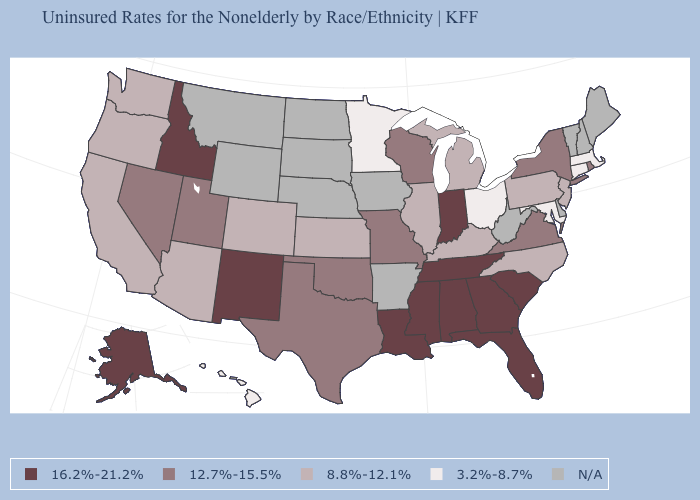Name the states that have a value in the range N/A?
Keep it brief. Arkansas, Delaware, Iowa, Maine, Montana, Nebraska, New Hampshire, North Dakota, South Dakota, Vermont, West Virginia, Wyoming. Among the states that border Louisiana , which have the lowest value?
Concise answer only. Texas. Among the states that border North Carolina , which have the highest value?
Concise answer only. Georgia, South Carolina, Tennessee. What is the value of Iowa?
Write a very short answer. N/A. Among the states that border Ohio , does Indiana have the highest value?
Write a very short answer. Yes. What is the value of New Jersey?
Answer briefly. 8.8%-12.1%. Name the states that have a value in the range 12.7%-15.5%?
Give a very brief answer. Missouri, Nevada, New York, Oklahoma, Rhode Island, Texas, Utah, Virginia, Wisconsin. What is the highest value in the USA?
Be succinct. 16.2%-21.2%. Name the states that have a value in the range 3.2%-8.7%?
Be succinct. Connecticut, Hawaii, Maryland, Massachusetts, Minnesota, Ohio. Does the map have missing data?
Short answer required. Yes. What is the highest value in the USA?
Keep it brief. 16.2%-21.2%. Which states have the lowest value in the USA?
Give a very brief answer. Connecticut, Hawaii, Maryland, Massachusetts, Minnesota, Ohio. Does Minnesota have the lowest value in the MidWest?
Be succinct. Yes. 